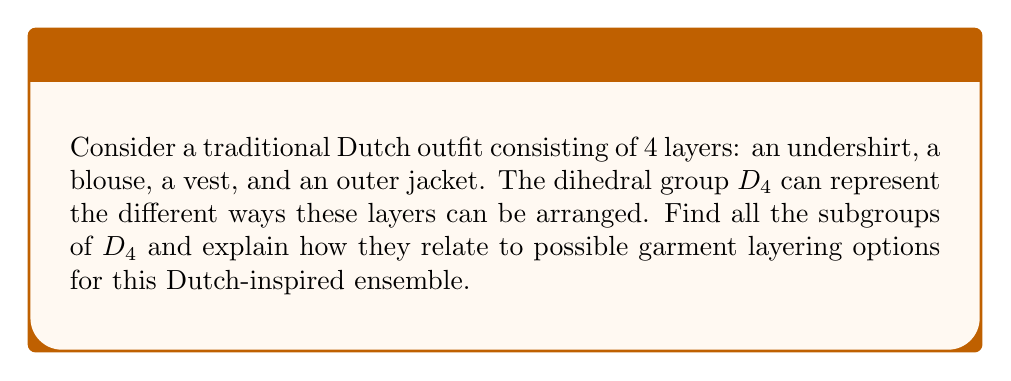Can you solve this math problem? To solve this problem, let's follow these steps:

1) First, recall that the dihedral group $D_4$ has 8 elements:
   $$D_4 = \{e, r, r^2, r^3, s, sr, sr^2, sr^3\}$$
   where $e$ is the identity, $r$ is a rotation by 90°, and $s$ is a reflection.

2) The subgroups of $D_4$ are:

   a) $\{e\}$ - The trivial subgroup (order 1)
   b) $\{e, r^2\}$ - Cyclic subgroup of order 2
   c) $\{e, s\}$, $\{e, sr\}$, $\{e, sr^2\}$, $\{e, sr^3\}$ - Four reflection subgroups (order 2)
   d) $\{e, r, r^2, r^3\}$ - Cyclic subgroup of order 4
   e) $\{e, r^2, s, sr^2\}$, $\{e, r^2, sr, sr^3\}$ - Two dihedral subgroups of order 4
   f) $D_4$ itself - The entire group (order 8)

3) Now, let's interpret these subgroups in terms of garment layering:

   a) $\{e\}$ represents no change to the original layering.
   
   b) $\{e, r^2\}$ represents either keeping the original order or completely reversing it (inner becomes outer and vice versa).
   
   c) The reflection subgroups represent swapping two adjacent layers. For example, $\{e, s\}$ might represent the option to swap the vest and outer jacket.
   
   d) $\{e, r, r^2, r^3\}$ represents all possible rotations of the layers, maintaining their relative order but changing which layer is outermost.
   
   e) The dihedral subgroups of order 4 represent more complex combinations, such as the option to either rotate the layers or reflect them in a specific way.
   
   f) The full group $D_4$ represents all possible arrangements of the four layers.

4) This mathematical model allows the fashion designer to systematically explore different layering options while maintaining the integrity of the traditional Dutch style. It also ensures that all possible combinations are considered, potentially leading to innovative yet culturally respectful designs.
Answer: The subgroups of $D_4$ are:
1) $\{e\}$ (order 1)
2) $\{e, r^2\}$ (order 2)
3) $\{e, s\}$, $\{e, sr\}$, $\{e, sr^2\}$, $\{e, sr^3\}$ (four subgroups of order 2)
4) $\{e, r, r^2, r^3\}$ (order 4)
5) $\{e, r^2, s, sr^2\}$, $\{e, r^2, sr, sr^3\}$ (two subgroups of order 4)
6) $D_4$ itself (order 8)

Each subgroup represents a set of layering options for the traditional Dutch outfit, ranging from no changes to all possible arrangements. 